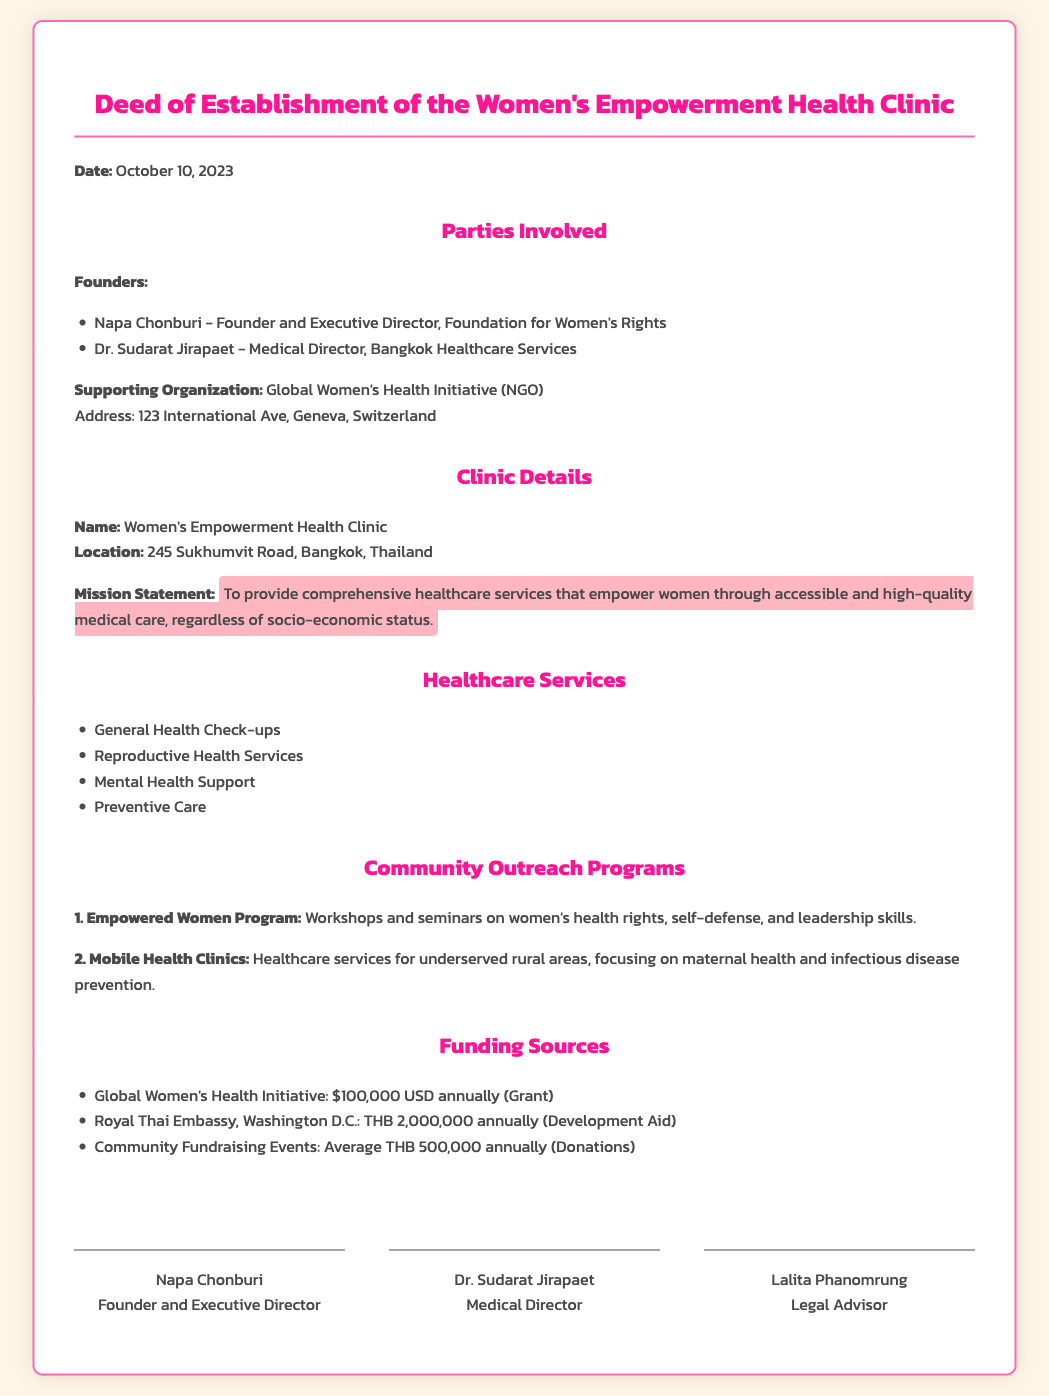What is the date of establishment? The date of establishment is mentioned at the beginning of the document.
Answer: October 10, 2023 Who is the Founder and Executive Director? This information is found under the "Parties Involved" section of the document.
Answer: Napa Chonburi What is the location of the Women's Empowerment Health Clinic? The clinic's location is stated in the "Clinic Details" section.
Answer: 245 Sukhumvit Road, Bangkok, Thailand What type of health services are offered? This can be found in the "Healthcare Services" section, listing the services provided.
Answer: General Health Check-ups What is the purpose of the Empowered Women Program? The purpose is outlined in the "Community Outreach Programs" section.
Answer: Workshops and seminars on women's health rights, self-defense, and leadership skills How much funding does the Global Women's Health Initiative provide annually? This information is in the "Funding Sources" section regarding specific funding amounts.
Answer: $100,000 USD What is the main mission statement of the clinic? The mission statement is highlighted in the "Clinic Details" section.
Answer: To provide comprehensive healthcare services that empower women through accessible and high-quality medical care, regardless of socio-economic status Who is responsible for the Medical Director position? This information is present in the "Parties Involved" section of the document.
Answer: Dr. Sudarat Jirapaet What organization supports the Women's Empowerment Health Clinic? This can be found under the "Parties Involved" section, mentioning the supporting organization.
Answer: Global Women's Health Initiative 